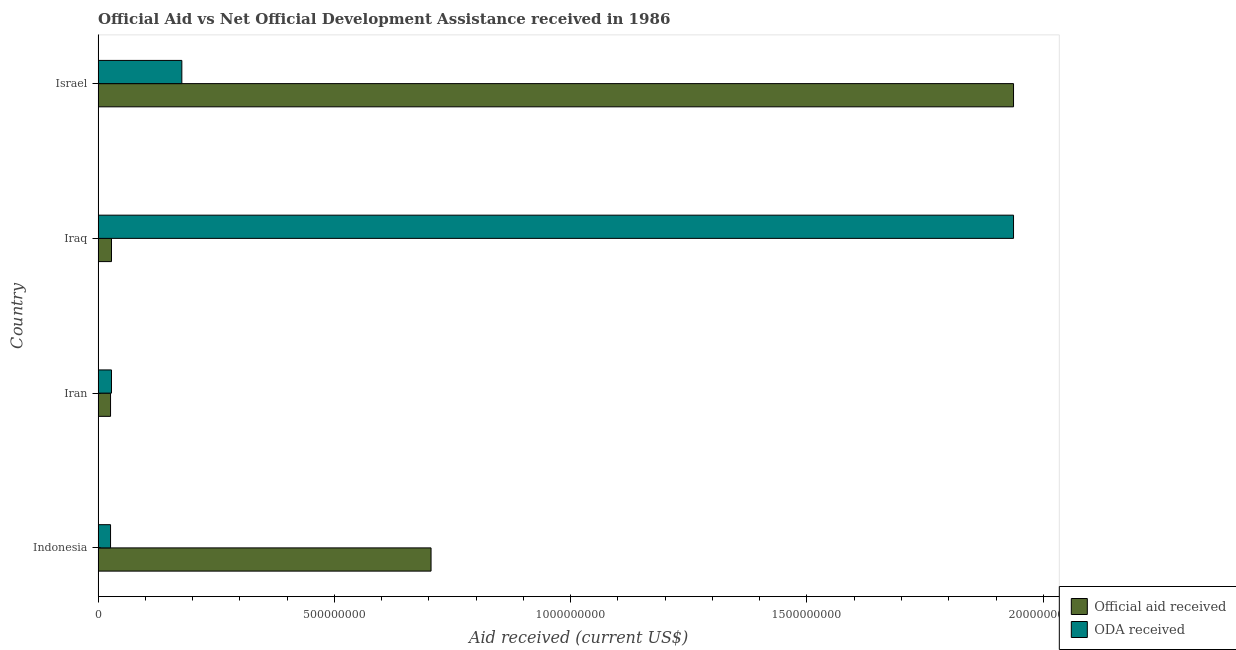How many different coloured bars are there?
Your answer should be very brief. 2. Are the number of bars on each tick of the Y-axis equal?
Give a very brief answer. Yes. How many bars are there on the 1st tick from the top?
Keep it short and to the point. 2. In how many cases, is the number of bars for a given country not equal to the number of legend labels?
Your answer should be very brief. 0. What is the official aid received in Indonesia?
Make the answer very short. 7.05e+08. Across all countries, what is the maximum oda received?
Your answer should be compact. 1.94e+09. Across all countries, what is the minimum official aid received?
Offer a very short reply. 2.63e+07. In which country was the oda received maximum?
Provide a succinct answer. Iraq. In which country was the official aid received minimum?
Make the answer very short. Iran. What is the total official aid received in the graph?
Keep it short and to the point. 2.70e+09. What is the difference between the oda received in Iraq and that in Israel?
Offer a very short reply. 1.76e+09. What is the difference between the oda received in Israel and the official aid received in Indonesia?
Give a very brief answer. -5.27e+08. What is the average oda received per country?
Give a very brief answer. 5.42e+08. What is the difference between the official aid received and oda received in Indonesia?
Your answer should be compact. 6.78e+08. In how many countries, is the official aid received greater than 200000000 US$?
Make the answer very short. 2. What is the ratio of the official aid received in Iraq to that in Israel?
Provide a succinct answer. 0.01. Is the difference between the official aid received in Iraq and Israel greater than the difference between the oda received in Iraq and Israel?
Offer a terse response. No. What is the difference between the highest and the second highest oda received?
Your answer should be compact. 1.76e+09. What is the difference between the highest and the lowest official aid received?
Your answer should be compact. 1.91e+09. What does the 2nd bar from the top in Iran represents?
Offer a very short reply. Official aid received. What does the 1st bar from the bottom in Israel represents?
Give a very brief answer. Official aid received. Are all the bars in the graph horizontal?
Ensure brevity in your answer.  Yes. How many countries are there in the graph?
Your response must be concise. 4. What is the difference between two consecutive major ticks on the X-axis?
Provide a short and direct response. 5.00e+08. Does the graph contain grids?
Provide a succinct answer. No. Where does the legend appear in the graph?
Ensure brevity in your answer.  Bottom right. How many legend labels are there?
Make the answer very short. 2. How are the legend labels stacked?
Your response must be concise. Vertical. What is the title of the graph?
Provide a succinct answer. Official Aid vs Net Official Development Assistance received in 1986 . What is the label or title of the X-axis?
Your answer should be compact. Aid received (current US$). What is the label or title of the Y-axis?
Your answer should be compact. Country. What is the Aid received (current US$) in Official aid received in Indonesia?
Your answer should be compact. 7.05e+08. What is the Aid received (current US$) in ODA received in Indonesia?
Ensure brevity in your answer.  2.63e+07. What is the Aid received (current US$) of Official aid received in Iran?
Your response must be concise. 2.63e+07. What is the Aid received (current US$) in ODA received in Iran?
Keep it short and to the point. 2.83e+07. What is the Aid received (current US$) in Official aid received in Iraq?
Your response must be concise. 2.83e+07. What is the Aid received (current US$) of ODA received in Iraq?
Provide a short and direct response. 1.94e+09. What is the Aid received (current US$) of Official aid received in Israel?
Ensure brevity in your answer.  1.94e+09. What is the Aid received (current US$) of ODA received in Israel?
Your answer should be very brief. 1.77e+08. Across all countries, what is the maximum Aid received (current US$) of Official aid received?
Provide a succinct answer. 1.94e+09. Across all countries, what is the maximum Aid received (current US$) in ODA received?
Provide a succinct answer. 1.94e+09. Across all countries, what is the minimum Aid received (current US$) in Official aid received?
Your answer should be compact. 2.63e+07. Across all countries, what is the minimum Aid received (current US$) of ODA received?
Provide a succinct answer. 2.63e+07. What is the total Aid received (current US$) of Official aid received in the graph?
Provide a succinct answer. 2.70e+09. What is the total Aid received (current US$) in ODA received in the graph?
Keep it short and to the point. 2.17e+09. What is the difference between the Aid received (current US$) of Official aid received in Indonesia and that in Iran?
Give a very brief answer. 6.78e+08. What is the difference between the Aid received (current US$) in ODA received in Indonesia and that in Iran?
Give a very brief answer. -1.97e+06. What is the difference between the Aid received (current US$) in Official aid received in Indonesia and that in Iraq?
Provide a succinct answer. 6.76e+08. What is the difference between the Aid received (current US$) of ODA received in Indonesia and that in Iraq?
Offer a very short reply. -1.91e+09. What is the difference between the Aid received (current US$) of Official aid received in Indonesia and that in Israel?
Provide a succinct answer. -1.23e+09. What is the difference between the Aid received (current US$) of ODA received in Indonesia and that in Israel?
Ensure brevity in your answer.  -1.51e+08. What is the difference between the Aid received (current US$) in Official aid received in Iran and that in Iraq?
Offer a terse response. -1.97e+06. What is the difference between the Aid received (current US$) in ODA received in Iran and that in Iraq?
Provide a succinct answer. -1.91e+09. What is the difference between the Aid received (current US$) of Official aid received in Iran and that in Israel?
Your response must be concise. -1.91e+09. What is the difference between the Aid received (current US$) in ODA received in Iran and that in Israel?
Keep it short and to the point. -1.49e+08. What is the difference between the Aid received (current US$) of Official aid received in Iraq and that in Israel?
Offer a very short reply. -1.91e+09. What is the difference between the Aid received (current US$) in ODA received in Iraq and that in Israel?
Ensure brevity in your answer.  1.76e+09. What is the difference between the Aid received (current US$) in Official aid received in Indonesia and the Aid received (current US$) in ODA received in Iran?
Your answer should be compact. 6.76e+08. What is the difference between the Aid received (current US$) in Official aid received in Indonesia and the Aid received (current US$) in ODA received in Iraq?
Offer a very short reply. -1.23e+09. What is the difference between the Aid received (current US$) in Official aid received in Indonesia and the Aid received (current US$) in ODA received in Israel?
Make the answer very short. 5.27e+08. What is the difference between the Aid received (current US$) of Official aid received in Iran and the Aid received (current US$) of ODA received in Iraq?
Ensure brevity in your answer.  -1.91e+09. What is the difference between the Aid received (current US$) in Official aid received in Iran and the Aid received (current US$) in ODA received in Israel?
Provide a short and direct response. -1.51e+08. What is the difference between the Aid received (current US$) of Official aid received in Iraq and the Aid received (current US$) of ODA received in Israel?
Make the answer very short. -1.49e+08. What is the average Aid received (current US$) in Official aid received per country?
Provide a short and direct response. 6.74e+08. What is the average Aid received (current US$) in ODA received per country?
Keep it short and to the point. 5.42e+08. What is the difference between the Aid received (current US$) of Official aid received and Aid received (current US$) of ODA received in Indonesia?
Keep it short and to the point. 6.78e+08. What is the difference between the Aid received (current US$) of Official aid received and Aid received (current US$) of ODA received in Iran?
Your answer should be compact. -1.97e+06. What is the difference between the Aid received (current US$) in Official aid received and Aid received (current US$) in ODA received in Iraq?
Provide a succinct answer. -1.91e+09. What is the difference between the Aid received (current US$) in Official aid received and Aid received (current US$) in ODA received in Israel?
Keep it short and to the point. 1.76e+09. What is the ratio of the Aid received (current US$) of Official aid received in Indonesia to that in Iran?
Provide a short and direct response. 26.78. What is the ratio of the Aid received (current US$) of ODA received in Indonesia to that in Iran?
Provide a short and direct response. 0.93. What is the ratio of the Aid received (current US$) of Official aid received in Indonesia to that in Iraq?
Provide a succinct answer. 24.91. What is the ratio of the Aid received (current US$) in ODA received in Indonesia to that in Iraq?
Your answer should be very brief. 0.01. What is the ratio of the Aid received (current US$) of Official aid received in Indonesia to that in Israel?
Keep it short and to the point. 0.36. What is the ratio of the Aid received (current US$) in ODA received in Indonesia to that in Israel?
Keep it short and to the point. 0.15. What is the ratio of the Aid received (current US$) in Official aid received in Iran to that in Iraq?
Offer a very short reply. 0.93. What is the ratio of the Aid received (current US$) in ODA received in Iran to that in Iraq?
Offer a very short reply. 0.01. What is the ratio of the Aid received (current US$) of Official aid received in Iran to that in Israel?
Offer a terse response. 0.01. What is the ratio of the Aid received (current US$) in ODA received in Iran to that in Israel?
Your response must be concise. 0.16. What is the ratio of the Aid received (current US$) of Official aid received in Iraq to that in Israel?
Offer a terse response. 0.01. What is the ratio of the Aid received (current US$) of ODA received in Iraq to that in Israel?
Your answer should be compact. 10.93. What is the difference between the highest and the second highest Aid received (current US$) of Official aid received?
Provide a short and direct response. 1.23e+09. What is the difference between the highest and the second highest Aid received (current US$) in ODA received?
Provide a short and direct response. 1.76e+09. What is the difference between the highest and the lowest Aid received (current US$) in Official aid received?
Your answer should be very brief. 1.91e+09. What is the difference between the highest and the lowest Aid received (current US$) of ODA received?
Ensure brevity in your answer.  1.91e+09. 